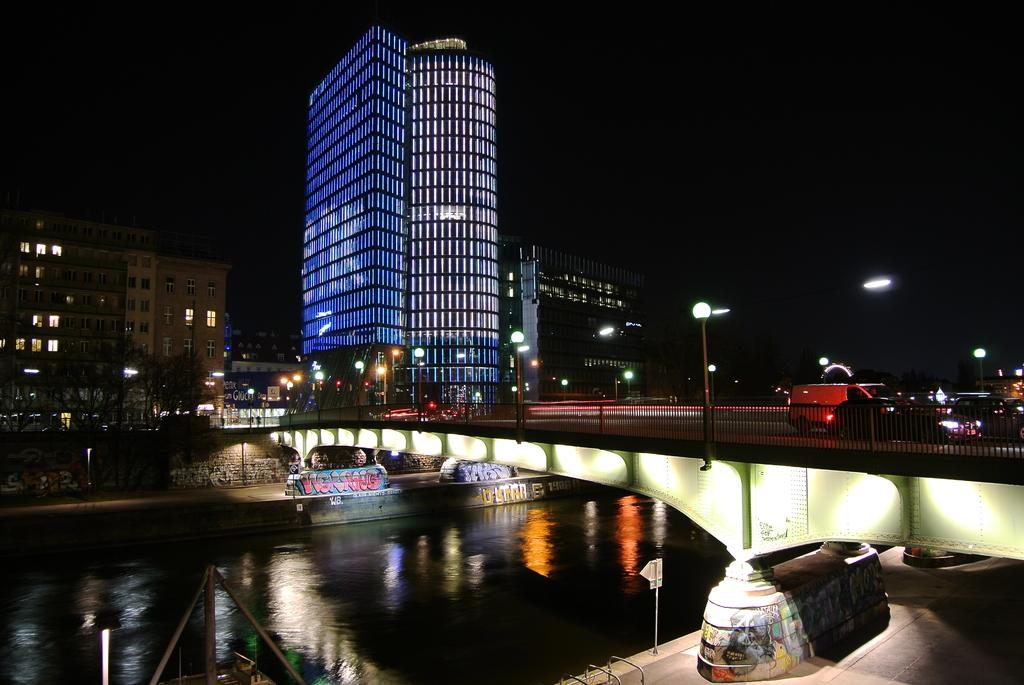What is happening on the bridge in the image? There are vehicles on a bridge in the image. What can be seen supporting the bridge or the poles in the image? There are poles in the image. What can be seen illuminating the bridge or the surrounding area in the image? There are lights in the image. What is visible beneath the bridge in the image? There is water visible in the image. What type of vegetation is present in the image? There are trees in the image. What type of structures are visible in the image? There are buildings with windows in the image. What type of platforms are present in the image? There are platforms in the image. How would you describe the overall lighting in the image? The background of the image is dark. Where is the brain located in the image? There is no brain present in the image. What type of channel can be seen in the image? There is no channel present in the image. 